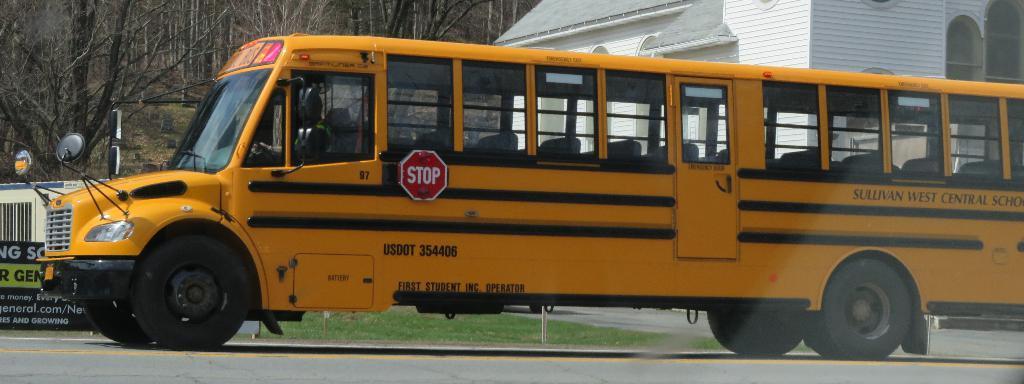Can you describe this image briefly? Here I can see a vehicle on the road. It is facing towards the left side. In the background there is a building and many trees. On the left side there is a board on which I can see some text. 